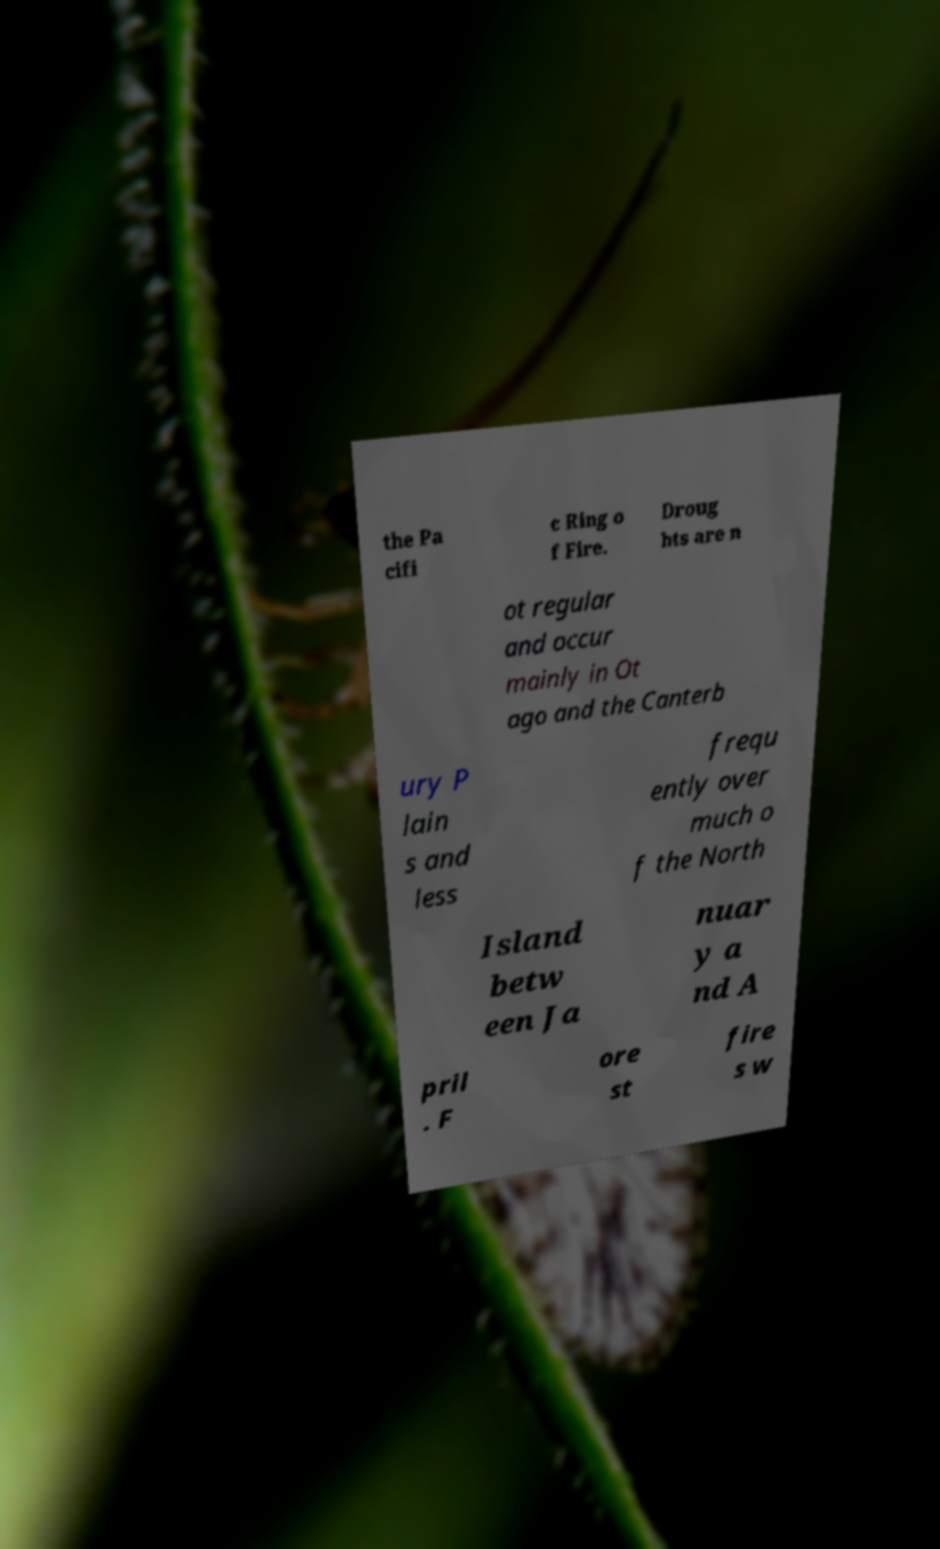What messages or text are displayed in this image? I need them in a readable, typed format. the Pa cifi c Ring o f Fire. Droug hts are n ot regular and occur mainly in Ot ago and the Canterb ury P lain s and less frequ ently over much o f the North Island betw een Ja nuar y a nd A pril . F ore st fire s w 